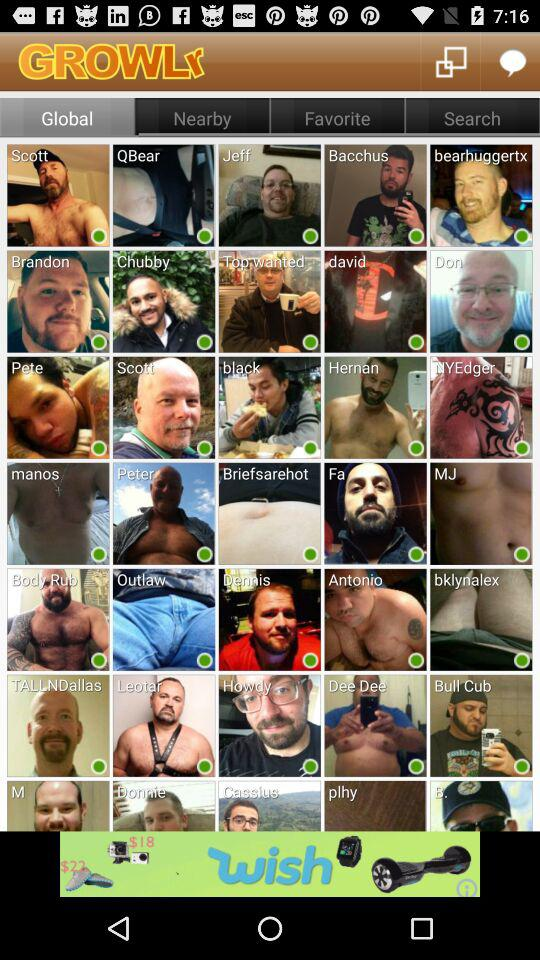What is the name of the application? The name of the application is "GROWLr". 